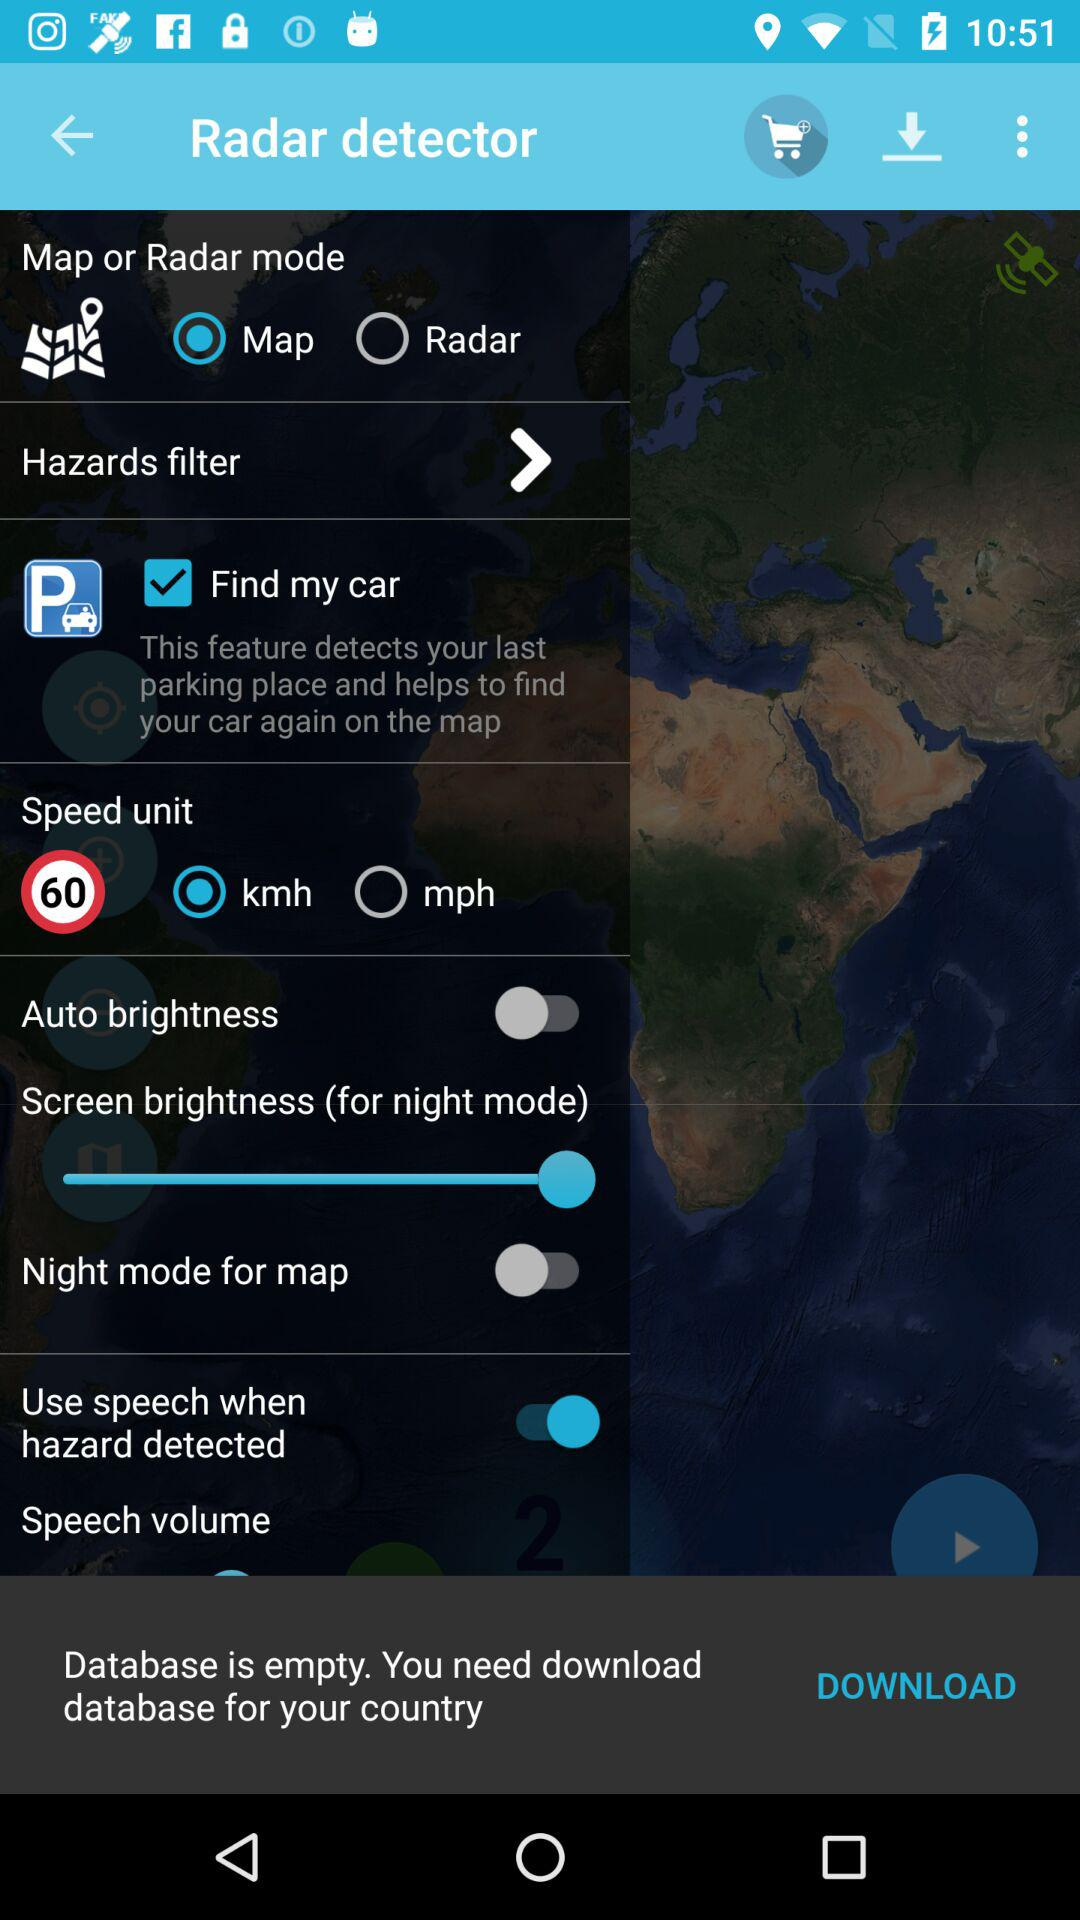What is the current state of "Use speech when hazard detected"? The current state is "on". 